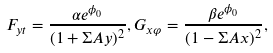Convert formula to latex. <formula><loc_0><loc_0><loc_500><loc_500>F _ { y t } = \frac { \alpha e ^ { \phi _ { 0 } } } { ( 1 + \Sigma A y ) ^ { 2 } } , G _ { x \varphi } = \frac { \beta e ^ { \phi _ { 0 } } } { ( 1 - \Sigma A x ) ^ { 2 } } ,</formula> 